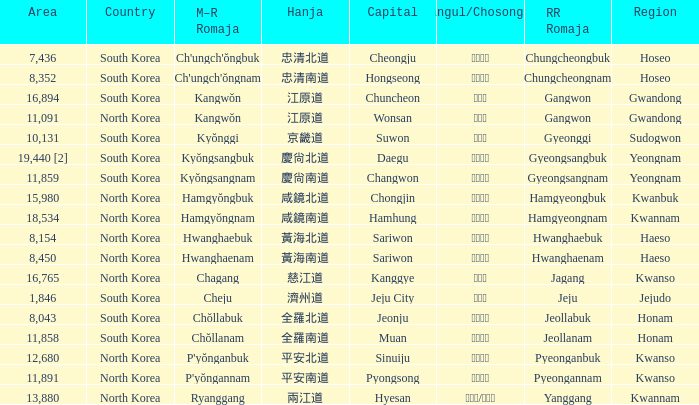Which country has a city with a Hanja of 平安北道? North Korea. 